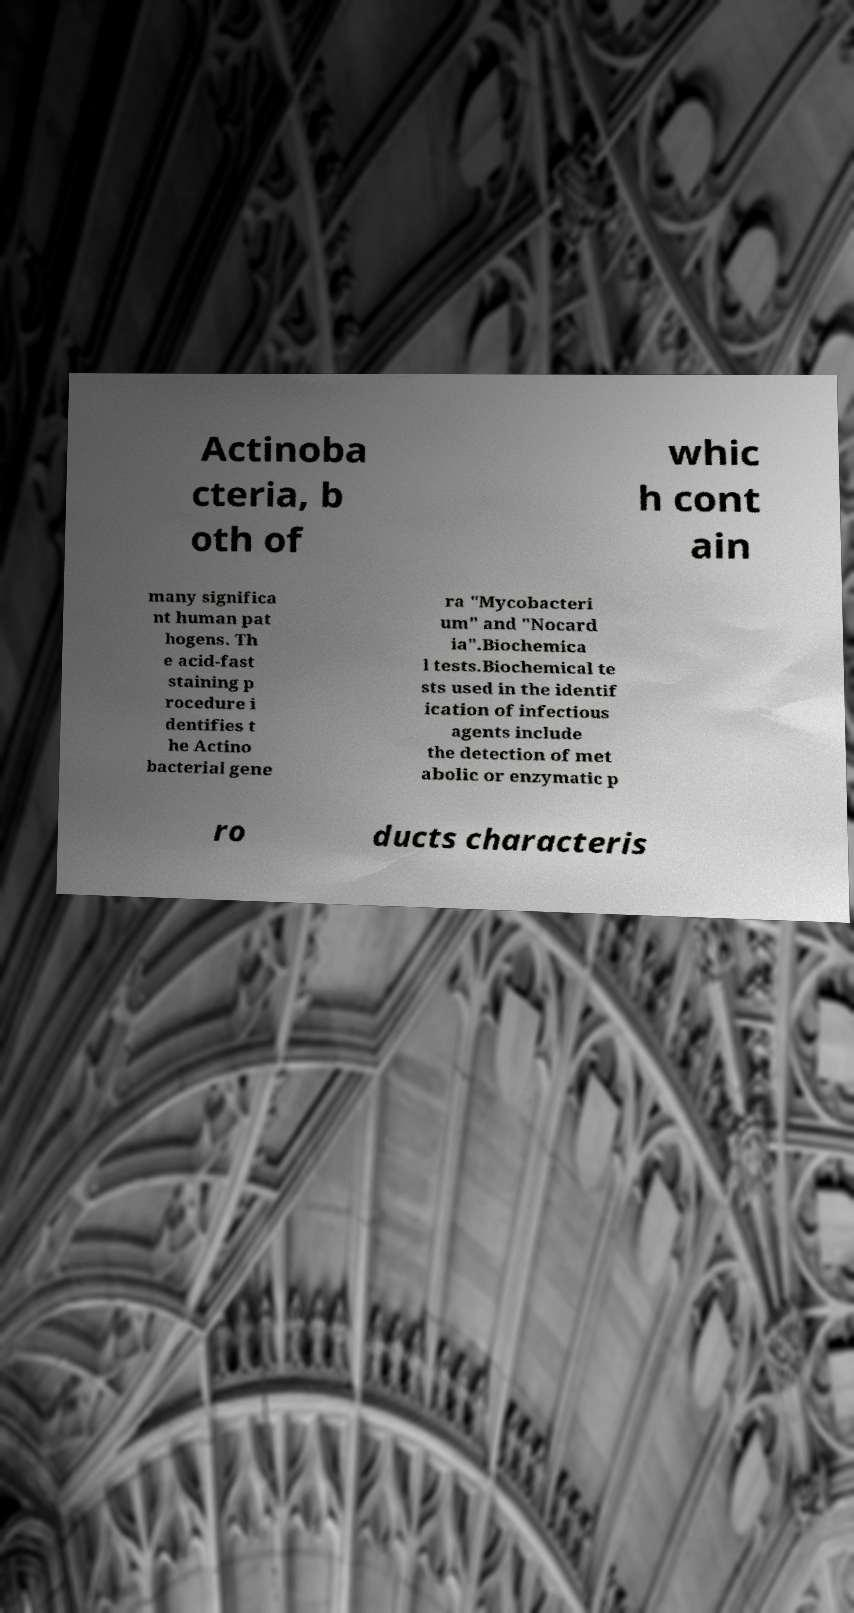Can you read and provide the text displayed in the image?This photo seems to have some interesting text. Can you extract and type it out for me? Actinoba cteria, b oth of whic h cont ain many significa nt human pat hogens. Th e acid-fast staining p rocedure i dentifies t he Actino bacterial gene ra "Mycobacteri um" and "Nocard ia".Biochemica l tests.Biochemical te sts used in the identif ication of infectious agents include the detection of met abolic or enzymatic p ro ducts characteris 